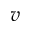Convert formula to latex. <formula><loc_0><loc_0><loc_500><loc_500>v</formula> 